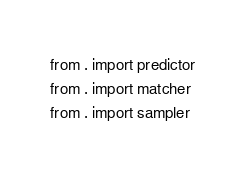<code> <loc_0><loc_0><loc_500><loc_500><_Python_>from . import predictor
from . import matcher
from . import sampler
</code> 